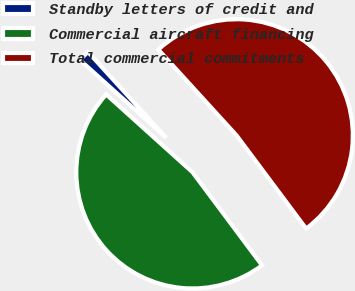<chart> <loc_0><loc_0><loc_500><loc_500><pie_chart><fcel>Standby letters of credit and<fcel>Commercial aircraft financing<fcel>Total commercial commitments<nl><fcel>1.56%<fcel>46.88%<fcel>51.56%<nl></chart> 